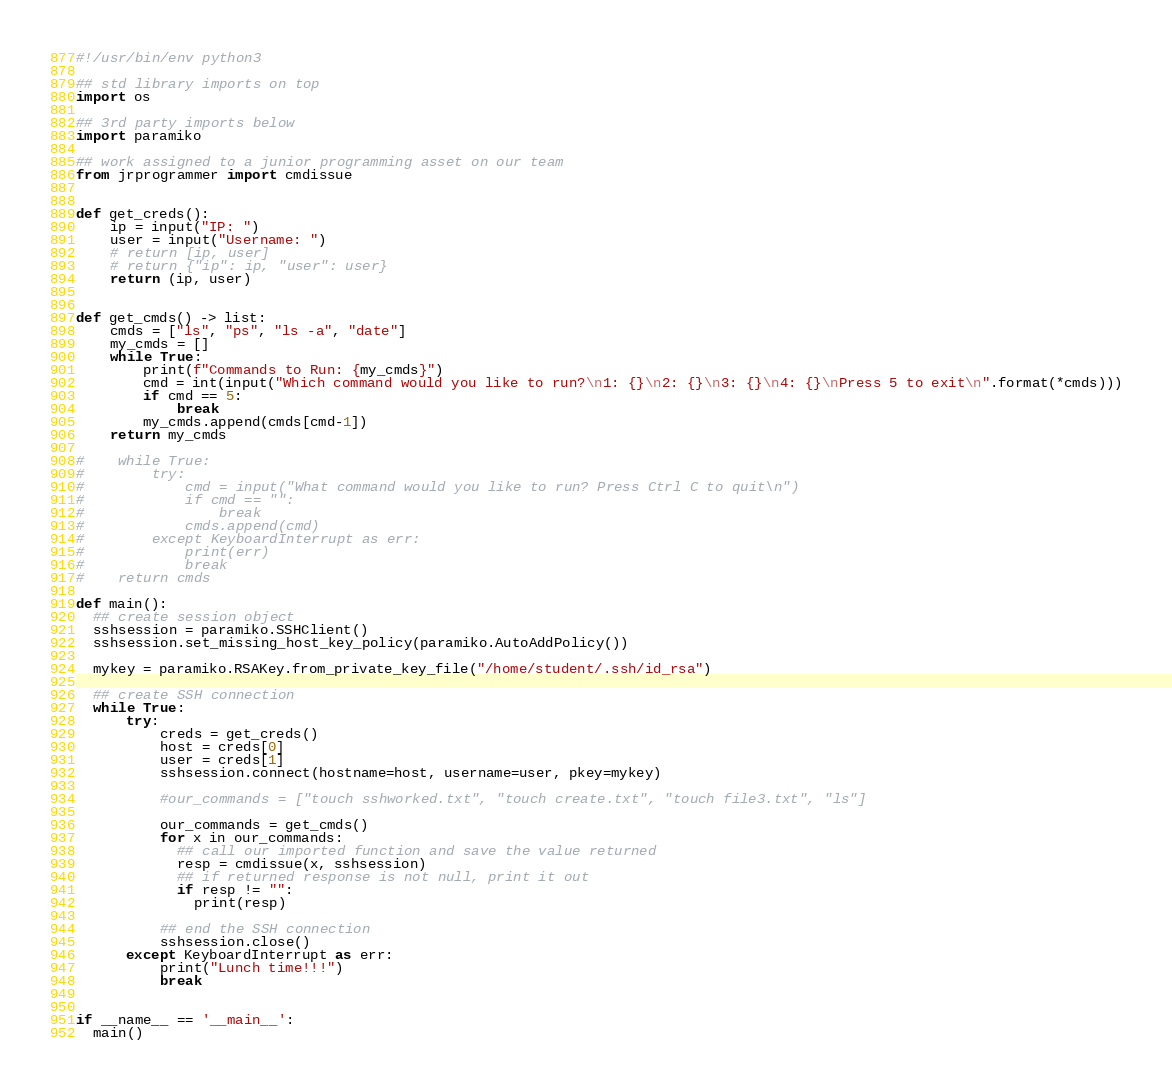Convert code to text. <code><loc_0><loc_0><loc_500><loc_500><_Python_>#!/usr/bin/env python3

## std library imports on top
import os

## 3rd party imports below
import paramiko

## work assigned to a junior programming asset on our team
from jrprogrammer import cmdissue


def get_creds():
    ip = input("IP: ")
    user = input("Username: ")
    # return [ip, user]
    # return {"ip": ip, "user": user}
    return (ip, user)


def get_cmds() -> list:
    cmds = ["ls", "ps", "ls -a", "date"]
    my_cmds = []
    while True:
        print(f"Commands to Run: {my_cmds}")
        cmd = int(input("Which command would you like to run?\n1: {}\n2: {}\n3: {}\n4: {}\nPress 5 to exit\n".format(*cmds)))
        if cmd == 5:
            break
        my_cmds.append(cmds[cmd-1])
    return my_cmds

#    while True:
#        try:
#            cmd = input("What command would you like to run? Press Ctrl C to quit\n")
#            if cmd == "":
#                break
#            cmds.append(cmd)
#        except KeyboardInterrupt as err:
#            print(err)
#            break
#    return cmds

def main():
  ## create session object
  sshsession = paramiko.SSHClient()
  sshsession.set_missing_host_key_policy(paramiko.AutoAddPolicy())

  mykey = paramiko.RSAKey.from_private_key_file("/home/student/.ssh/id_rsa")

  ## create SSH connection
  while True:
      try:
          creds = get_creds()
          host = creds[0]
          user = creds[1]
          sshsession.connect(hostname=host, username=user, pkey=mykey)
        
          #our_commands = ["touch sshworked.txt", "touch create.txt", "touch file3.txt", "ls"]
        
          our_commands = get_cmds()
          for x in our_commands:
            ## call our imported function and save the value returned
            resp = cmdissue(x, sshsession)
            ## if returned response is not null, print it out
            if resp != "":
              print(resp)
        
          ## end the SSH connection
          sshsession.close()
      except KeyboardInterrupt as err:
          print("Lunch time!!!")
          break


if __name__ == '__main__':
  main()
</code> 